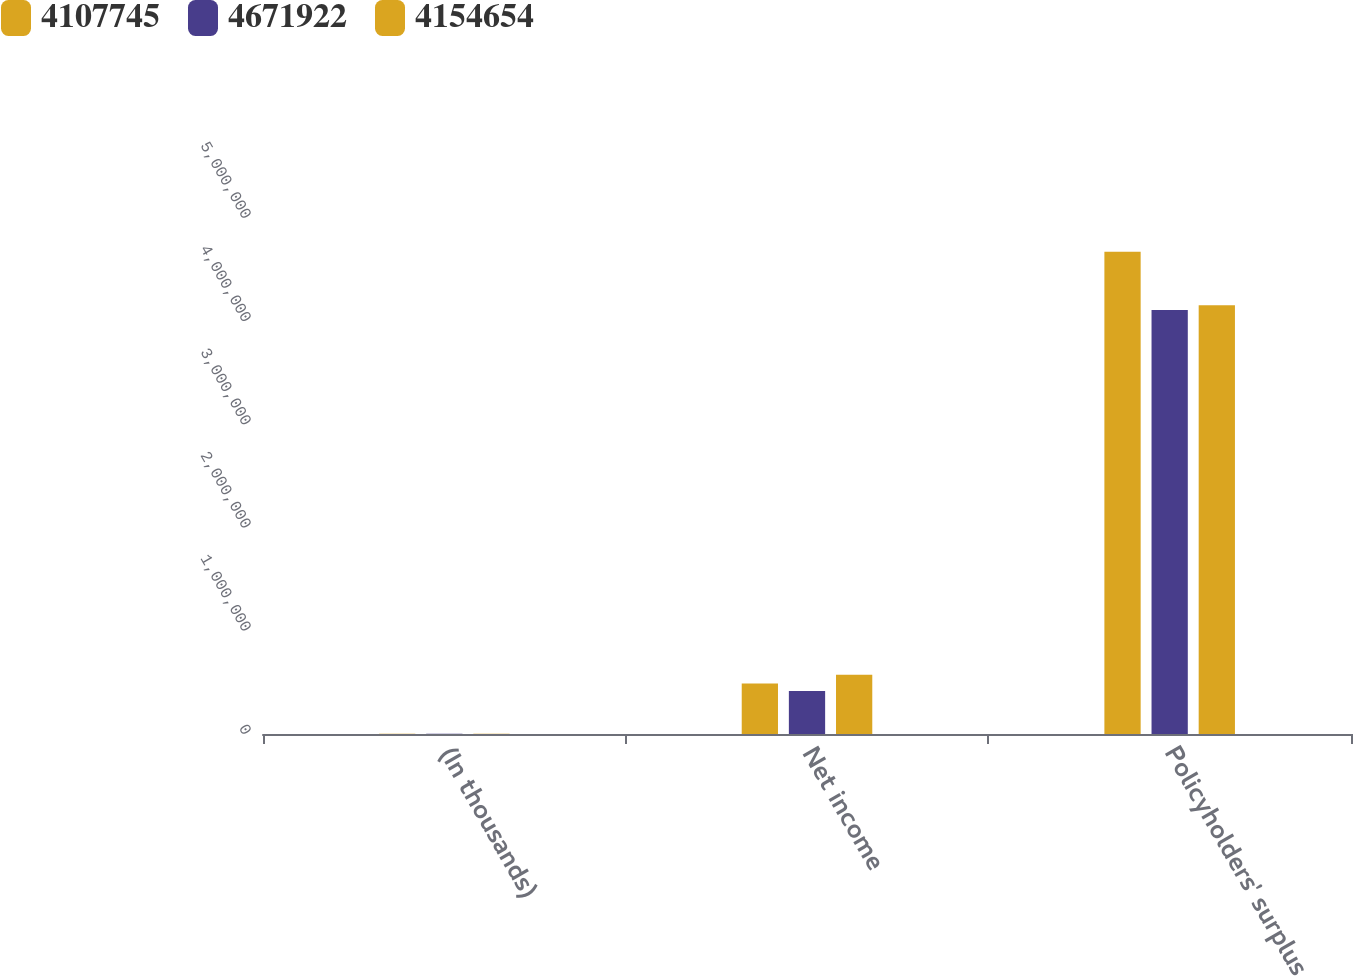<chart> <loc_0><loc_0><loc_500><loc_500><stacked_bar_chart><ecel><fcel>(In thousands)<fcel>Net income<fcel>Policyholders' surplus<nl><fcel>4.10774e+06<fcel>2012<fcel>490119<fcel>4.67192e+06<nl><fcel>4.67192e+06<fcel>2011<fcel>417441<fcel>4.10774e+06<nl><fcel>4.15465e+06<fcel>2010<fcel>574181<fcel>4.15465e+06<nl></chart> 